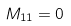<formula> <loc_0><loc_0><loc_500><loc_500>M _ { 1 1 } = 0</formula> 